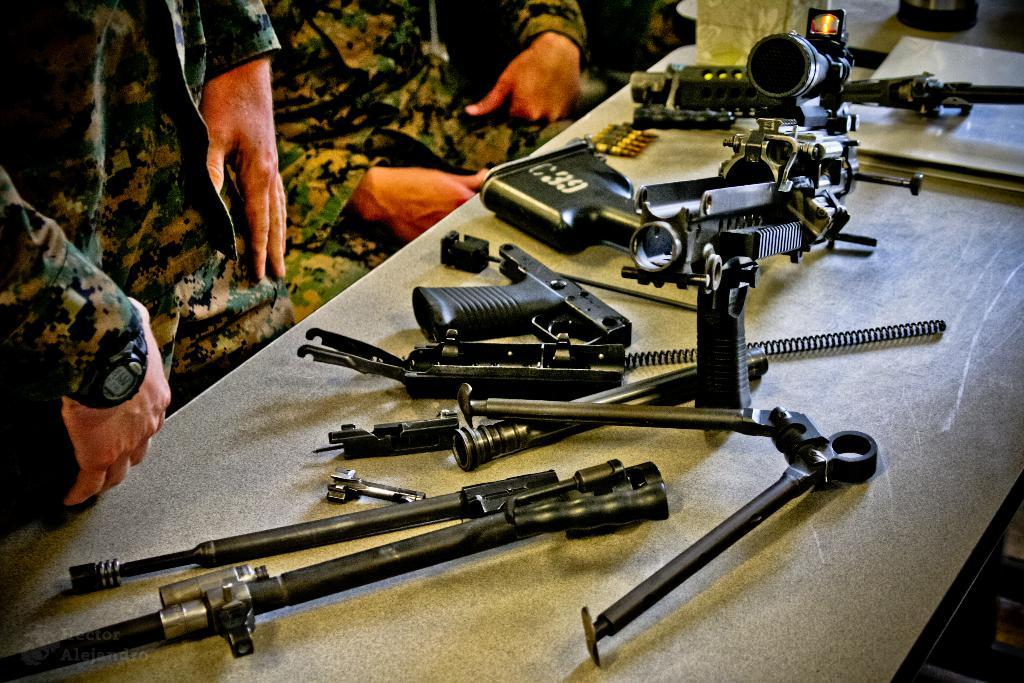What type of furniture is present in the image? There is a desk in the image. What items are on the desk? There are guns and gun parts visible on the desk. What ammunition is present in the image? There are bullets in the image. Who is present in the image? There are army personnel in uniform sitting near the desk. What type of plantation can be seen in the background of the image? There is no plantation visible in the image. What song is being sung by the army personnel in the image? There is no indication of any song being sung in the image. 